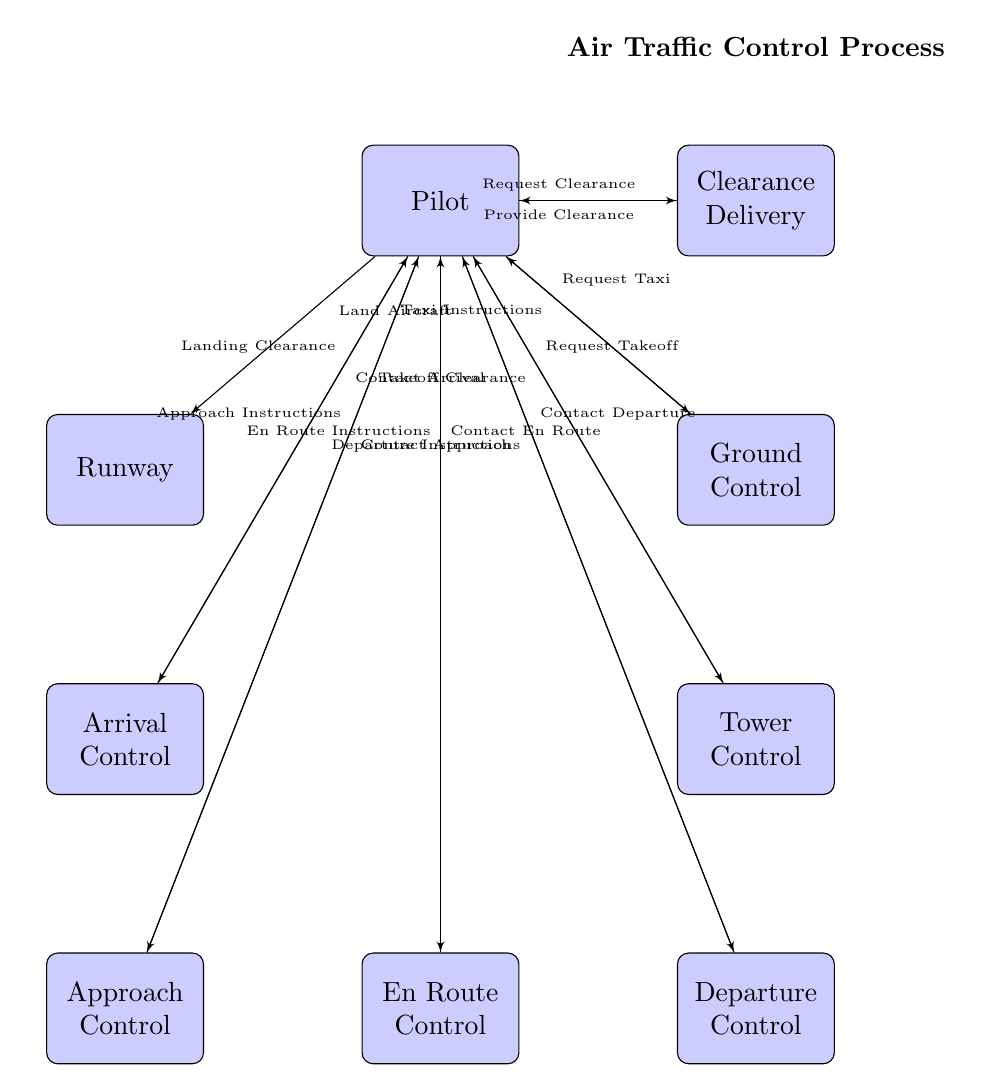What's the first action a pilot takes in the air traffic control process? The diagram shows that the first action a pilot takes is to request clearance from Clearance Delivery. This is indicated by the line connecting the Pilot to Clearance Delivery and the label "Request Clearance."
Answer: Request Clearance How many key decision points are depicted in the diagram? The diagram illustrates seven key decision points, represented by the nodes connected in a sequence from the Pilot through to the Runway. Each of the blocks signifies an individual decision point focused on a specific stage of the air traffic control process.
Answer: Seven What instructions does Approach Control provide to the pilot? The arrow from the Approach Control node to the Pilot node indicates the communication flow where Approach Control provides instructions. It is labeled "Approach Instructions," which reveals the type of guidance provided to the pilot in this phase.
Answer: Approach Instructions Which control do pilots contact after receiving takeoff clearance? The diagram outlines that once pilots receive takeoff clearance from the Tower Control, they are instructed to contact Departure Control, as indicated by the arrow showing the line from the Pilot to the Departure Control block.
Answer: Contact Departure What is the last action a pilot performs in the air traffic control process? The final action denoted in the diagram is for the pilot to land the aircraft, as indicated by the line connecting the Pilot to the Runway with the label "Land Aircraft." Hence, this is the concluding step of the air traffic control process depicted in the diagram.
Answer: Land Aircraft Which control provides landing clearance to the pilot? The diagram indicates that Arrival Control is the block that provides Landing Clearance to the pilot. This is reflected by the line connecting Arrival Control to the Pilot, labeled "Landing Clearance."
Answer: Arrival Control What is the role of Clearance Delivery in the process? Clearance Delivery's role is illustrated in the diagram as the entity that provides clearance to the pilot after a clearance request is made. This is shown by the connection labeled "Provide Clearance" from Clearance Delivery back to the Pilot.
Answer: Provide Clearance How does the communication flow from Ground Control to the Pilot occur? The diagram shows that Ground Control instructs the Pilot by sending Taxi Instructions. The line indicates that the flow of communication between these two blocks involves the Ground Control block delivering commands to assist the pilot in taxiing.
Answer: Taxi Instructions How many layers of control are shown in the diagram? The diagram displays four layers of control: Clearance Delivery, Ground Control, Tower Control, and Departure Control. Each layer represents a distinct level in the air traffic control process, emphasizing the structured hierarchy of communication throughout the flight stages.
Answer: Four 